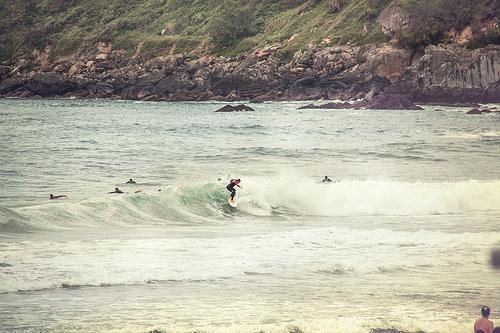How many surfers are riding the wave?
Give a very brief answer. 1. 